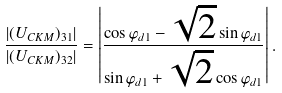Convert formula to latex. <formula><loc_0><loc_0><loc_500><loc_500>\frac { | ( U _ { C K M } ) _ { 3 1 } | } { | ( U _ { C K M } ) _ { 3 2 } | } = \left | \frac { \cos \varphi _ { d 1 } - \sqrt { 2 } \sin \varphi _ { d 1 } } { \sin \varphi _ { d 1 } + \sqrt { 2 } \cos \varphi _ { d 1 } } \right | .</formula> 